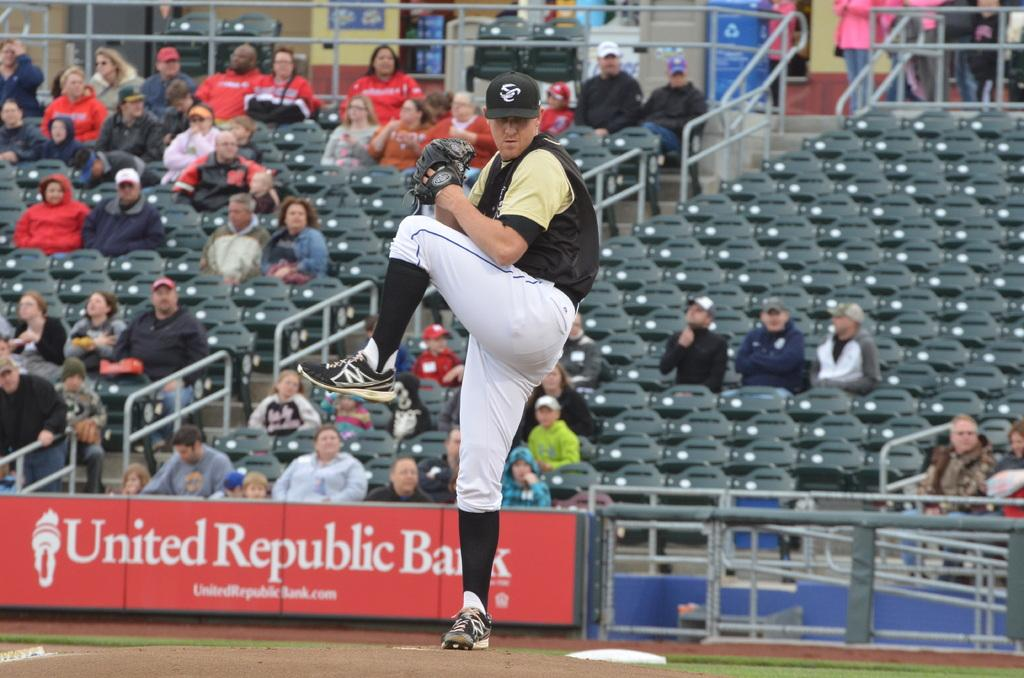Provide a one-sentence caption for the provided image. A pitcher winds up at an unknown stadium with a united republic bank banner behind him. 